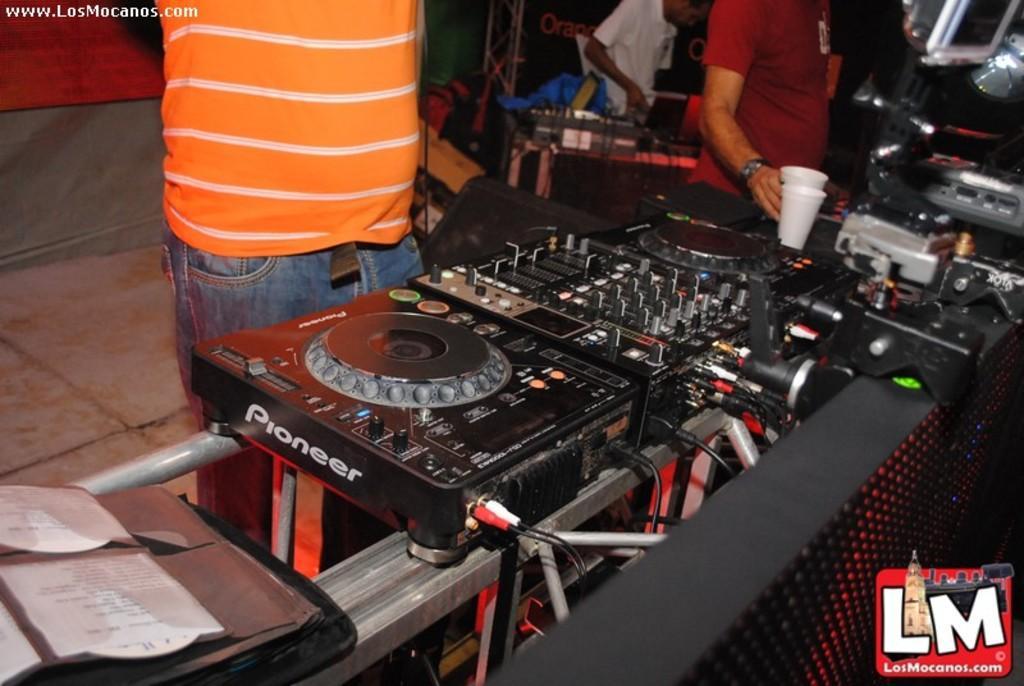Could you give a brief overview of what you see in this image? This image consists of three persons and we can see a DJ setup in the front along with the speakers. At the bottom, there is a floor. On the left, there is a CD case. In the front, there are two glasses kept. 